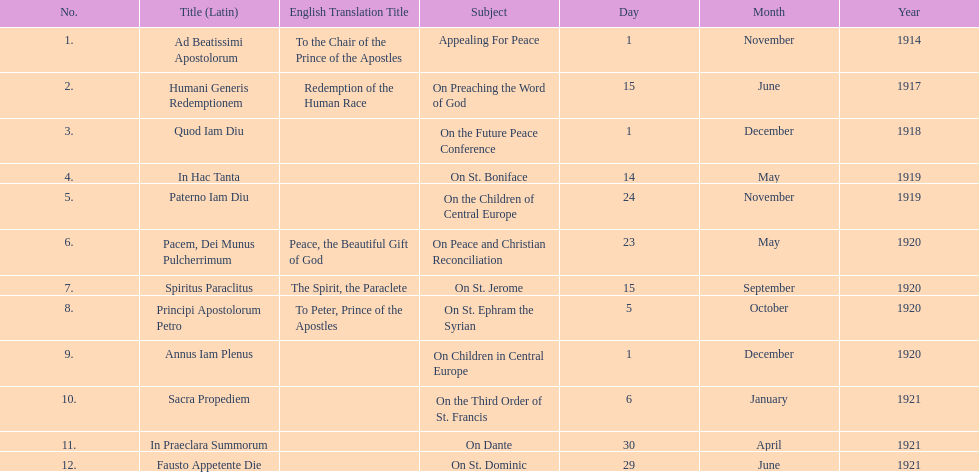How many titles are listed in the table? 12. 